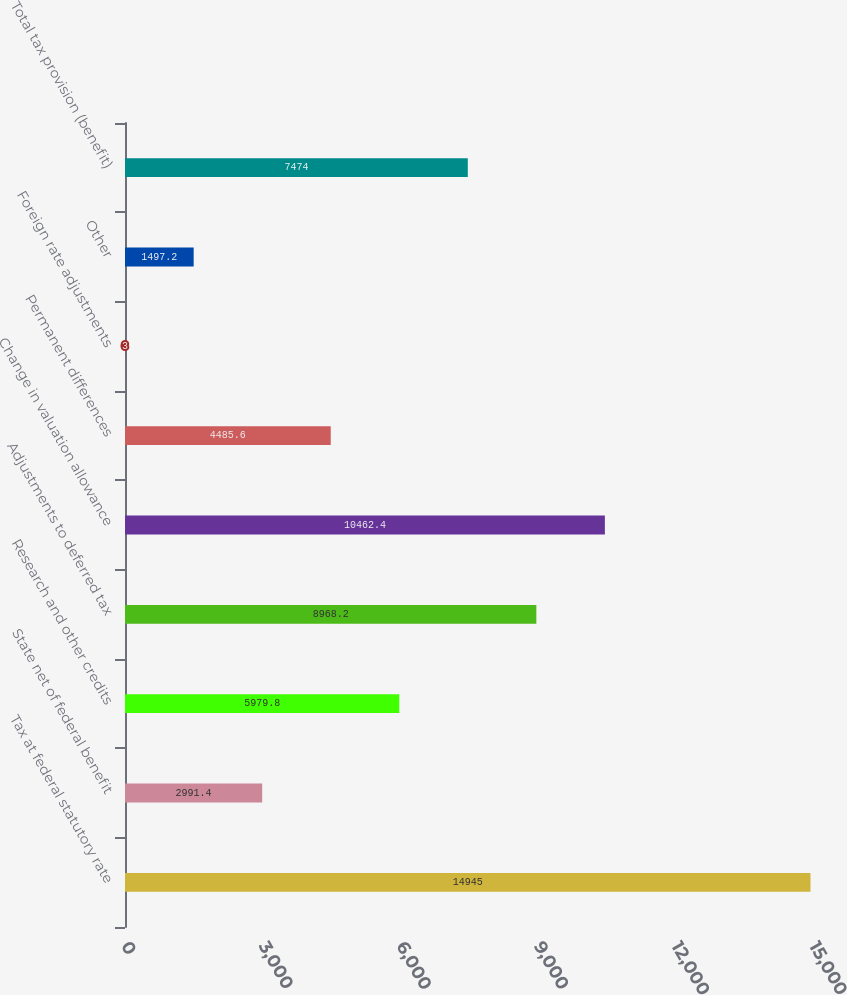<chart> <loc_0><loc_0><loc_500><loc_500><bar_chart><fcel>Tax at federal statutory rate<fcel>State net of federal benefit<fcel>Research and other credits<fcel>Adjustments to deferred tax<fcel>Change in valuation allowance<fcel>Permanent differences<fcel>Foreign rate adjustments<fcel>Other<fcel>Total tax provision (benefit)<nl><fcel>14945<fcel>2991.4<fcel>5979.8<fcel>8968.2<fcel>10462.4<fcel>4485.6<fcel>3<fcel>1497.2<fcel>7474<nl></chart> 